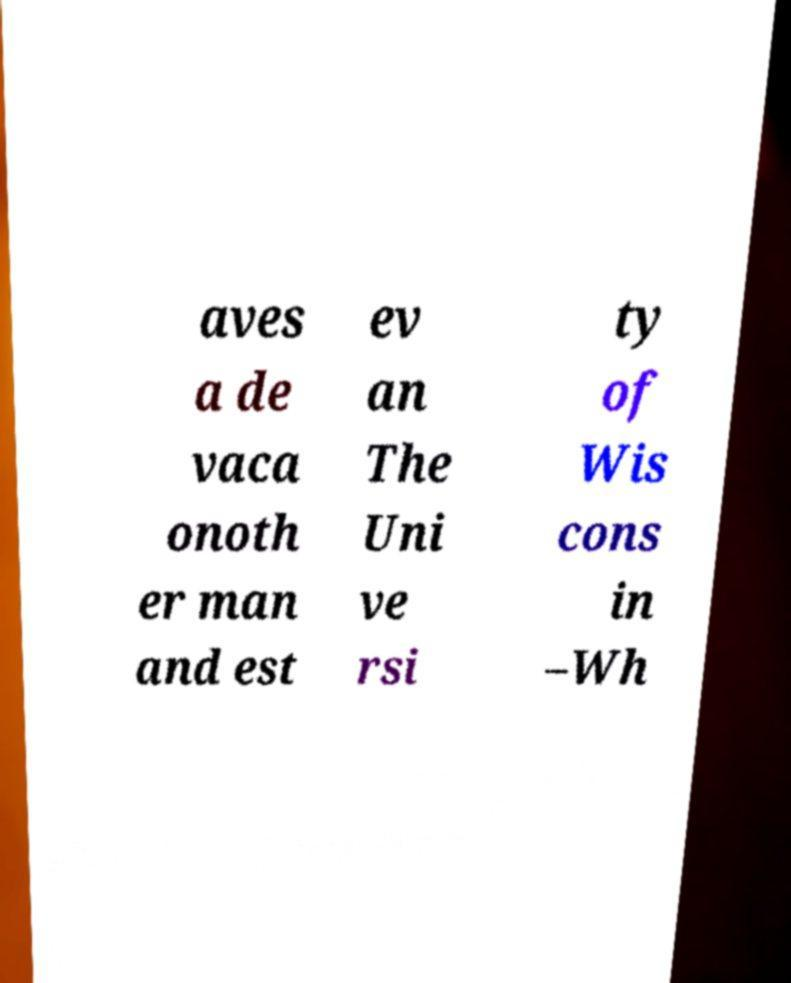Can you accurately transcribe the text from the provided image for me? aves a de vaca onoth er man and est ev an The Uni ve rsi ty of Wis cons in –Wh 